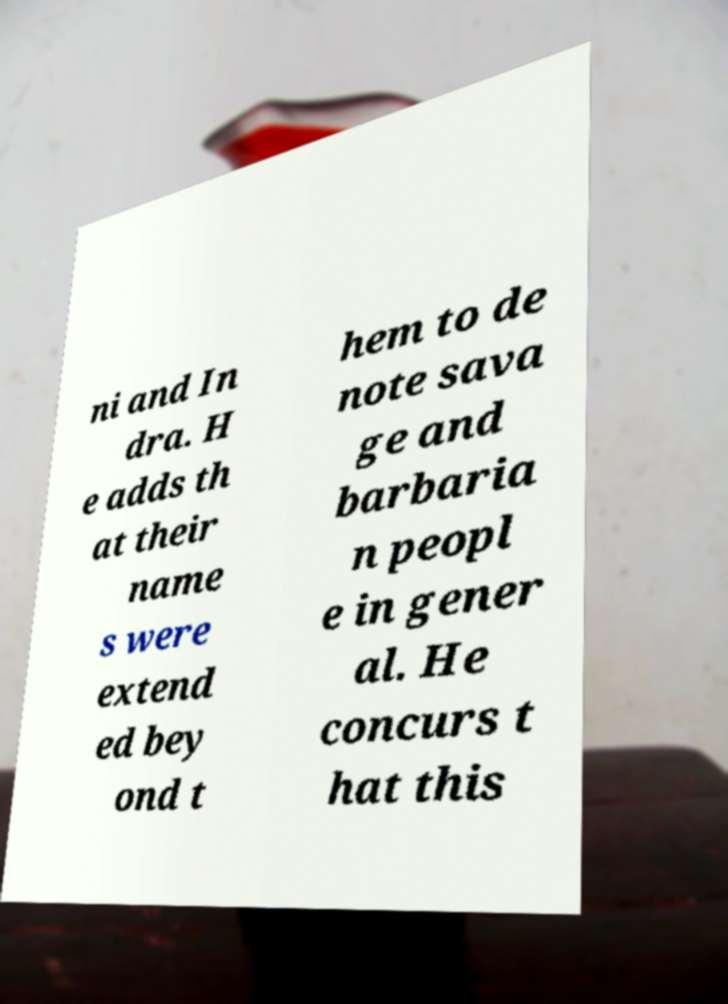What messages or text are displayed in this image? I need them in a readable, typed format. ni and In dra. H e adds th at their name s were extend ed bey ond t hem to de note sava ge and barbaria n peopl e in gener al. He concurs t hat this 